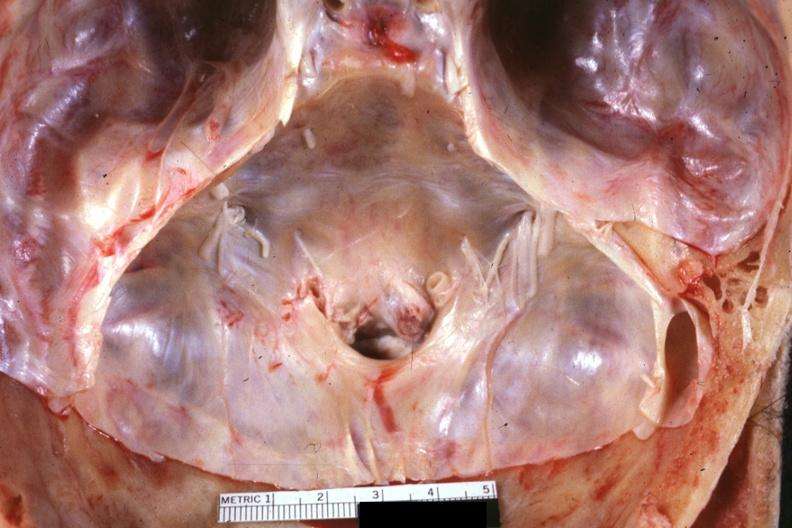does this image show stenotic foramen magnum in situs excellent example?
Answer the question using a single word or phrase. Yes 